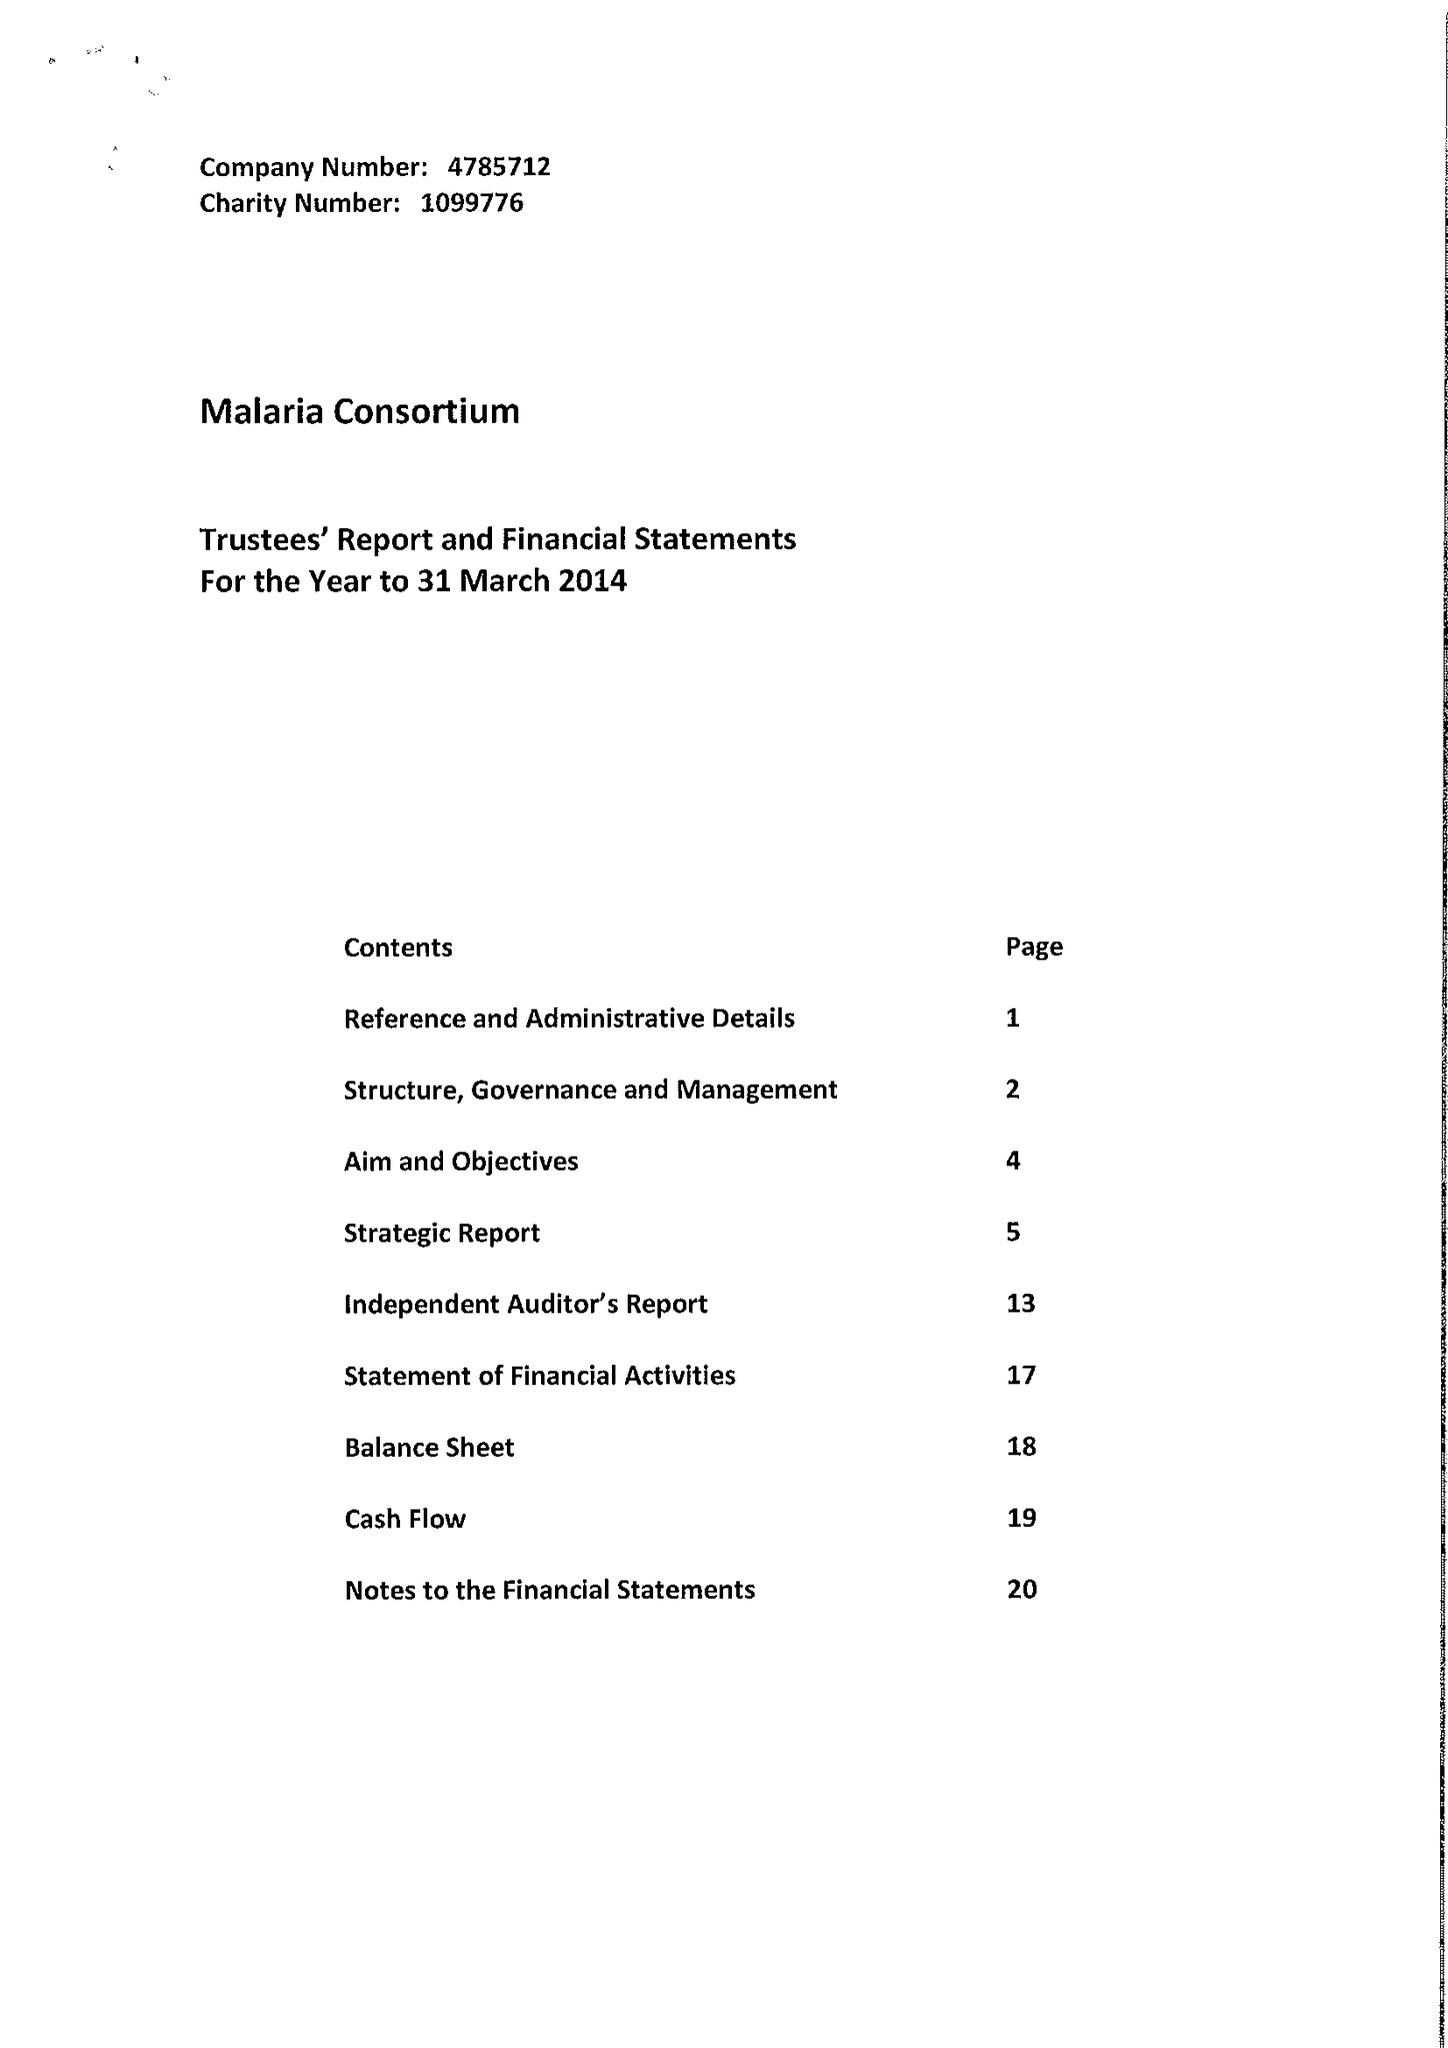What is the value for the report_date?
Answer the question using a single word or phrase. 2014-03-31 